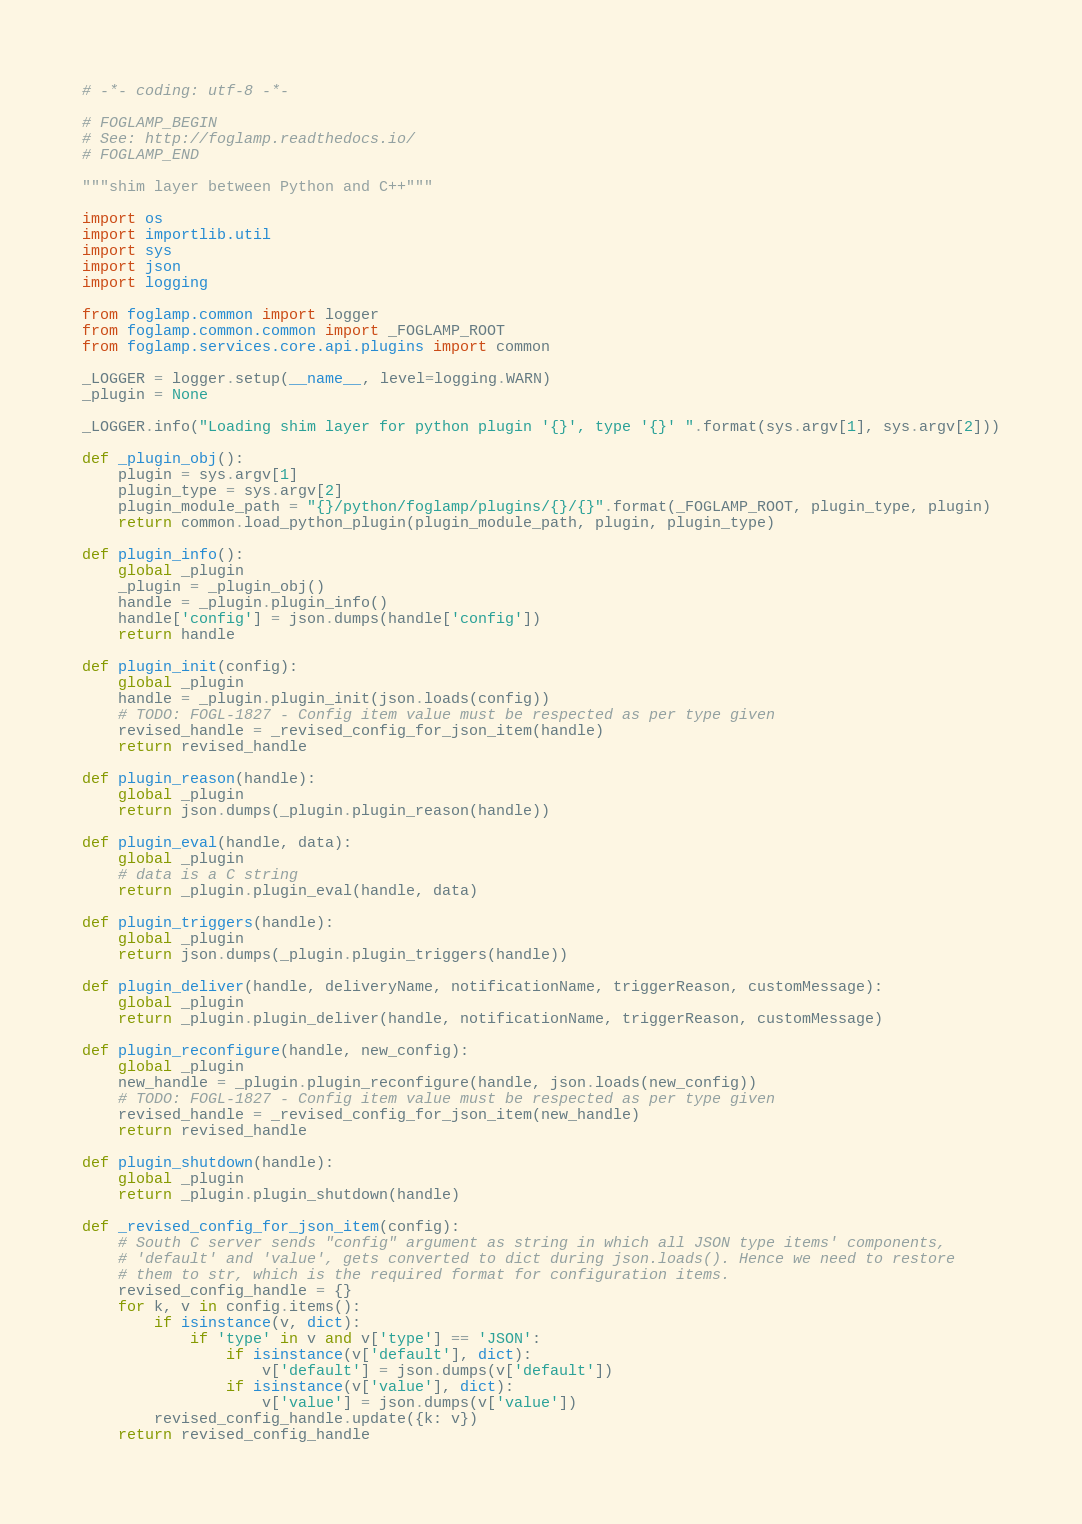Convert code to text. <code><loc_0><loc_0><loc_500><loc_500><_Python_># -*- coding: utf-8 -*-

# FOGLAMP_BEGIN
# See: http://foglamp.readthedocs.io/
# FOGLAMP_END

"""shim layer between Python and C++"""

import os
import importlib.util
import sys
import json
import logging

from foglamp.common import logger
from foglamp.common.common import _FOGLAMP_ROOT
from foglamp.services.core.api.plugins import common

_LOGGER = logger.setup(__name__, level=logging.WARN)
_plugin = None

_LOGGER.info("Loading shim layer for python plugin '{}', type '{}' ".format(sys.argv[1], sys.argv[2]))

def _plugin_obj():
    plugin = sys.argv[1]
    plugin_type = sys.argv[2]
    plugin_module_path = "{}/python/foglamp/plugins/{}/{}".format(_FOGLAMP_ROOT, plugin_type, plugin)
    return common.load_python_plugin(plugin_module_path, plugin, plugin_type)

def plugin_info():
    global _plugin
    _plugin = _plugin_obj()
    handle = _plugin.plugin_info()
    handle['config'] = json.dumps(handle['config'])
    return handle

def plugin_init(config):
    global _plugin
    handle = _plugin.plugin_init(json.loads(config))
    # TODO: FOGL-1827 - Config item value must be respected as per type given
    revised_handle = _revised_config_for_json_item(handle)
    return revised_handle

def plugin_reason(handle):
    global _plugin
    return json.dumps(_plugin.plugin_reason(handle))

def plugin_eval(handle, data):
    global _plugin
    # data is a C string
    return _plugin.plugin_eval(handle, data)

def plugin_triggers(handle):
    global _plugin
    return json.dumps(_plugin.plugin_triggers(handle))

def plugin_deliver(handle, deliveryName, notificationName, triggerReason, customMessage):
    global _plugin
    return _plugin.plugin_deliver(handle, notificationName, triggerReason, customMessage)

def plugin_reconfigure(handle, new_config):
    global _plugin
    new_handle = _plugin.plugin_reconfigure(handle, json.loads(new_config))
    # TODO: FOGL-1827 - Config item value must be respected as per type given
    revised_handle = _revised_config_for_json_item(new_handle)
    return revised_handle

def plugin_shutdown(handle):
    global _plugin
    return _plugin.plugin_shutdown(handle)

def _revised_config_for_json_item(config):
    # South C server sends "config" argument as string in which all JSON type items' components,
    # 'default' and 'value', gets converted to dict during json.loads(). Hence we need to restore
    # them to str, which is the required format for configuration items.
    revised_config_handle = {}
    for k, v in config.items():
        if isinstance(v, dict):
            if 'type' in v and v['type'] == 'JSON':
                if isinstance(v['default'], dict):
                    v['default'] = json.dumps(v['default'])
                if isinstance(v['value'], dict):
                    v['value'] = json.dumps(v['value'])
        revised_config_handle.update({k: v})
    return revised_config_handle
</code> 